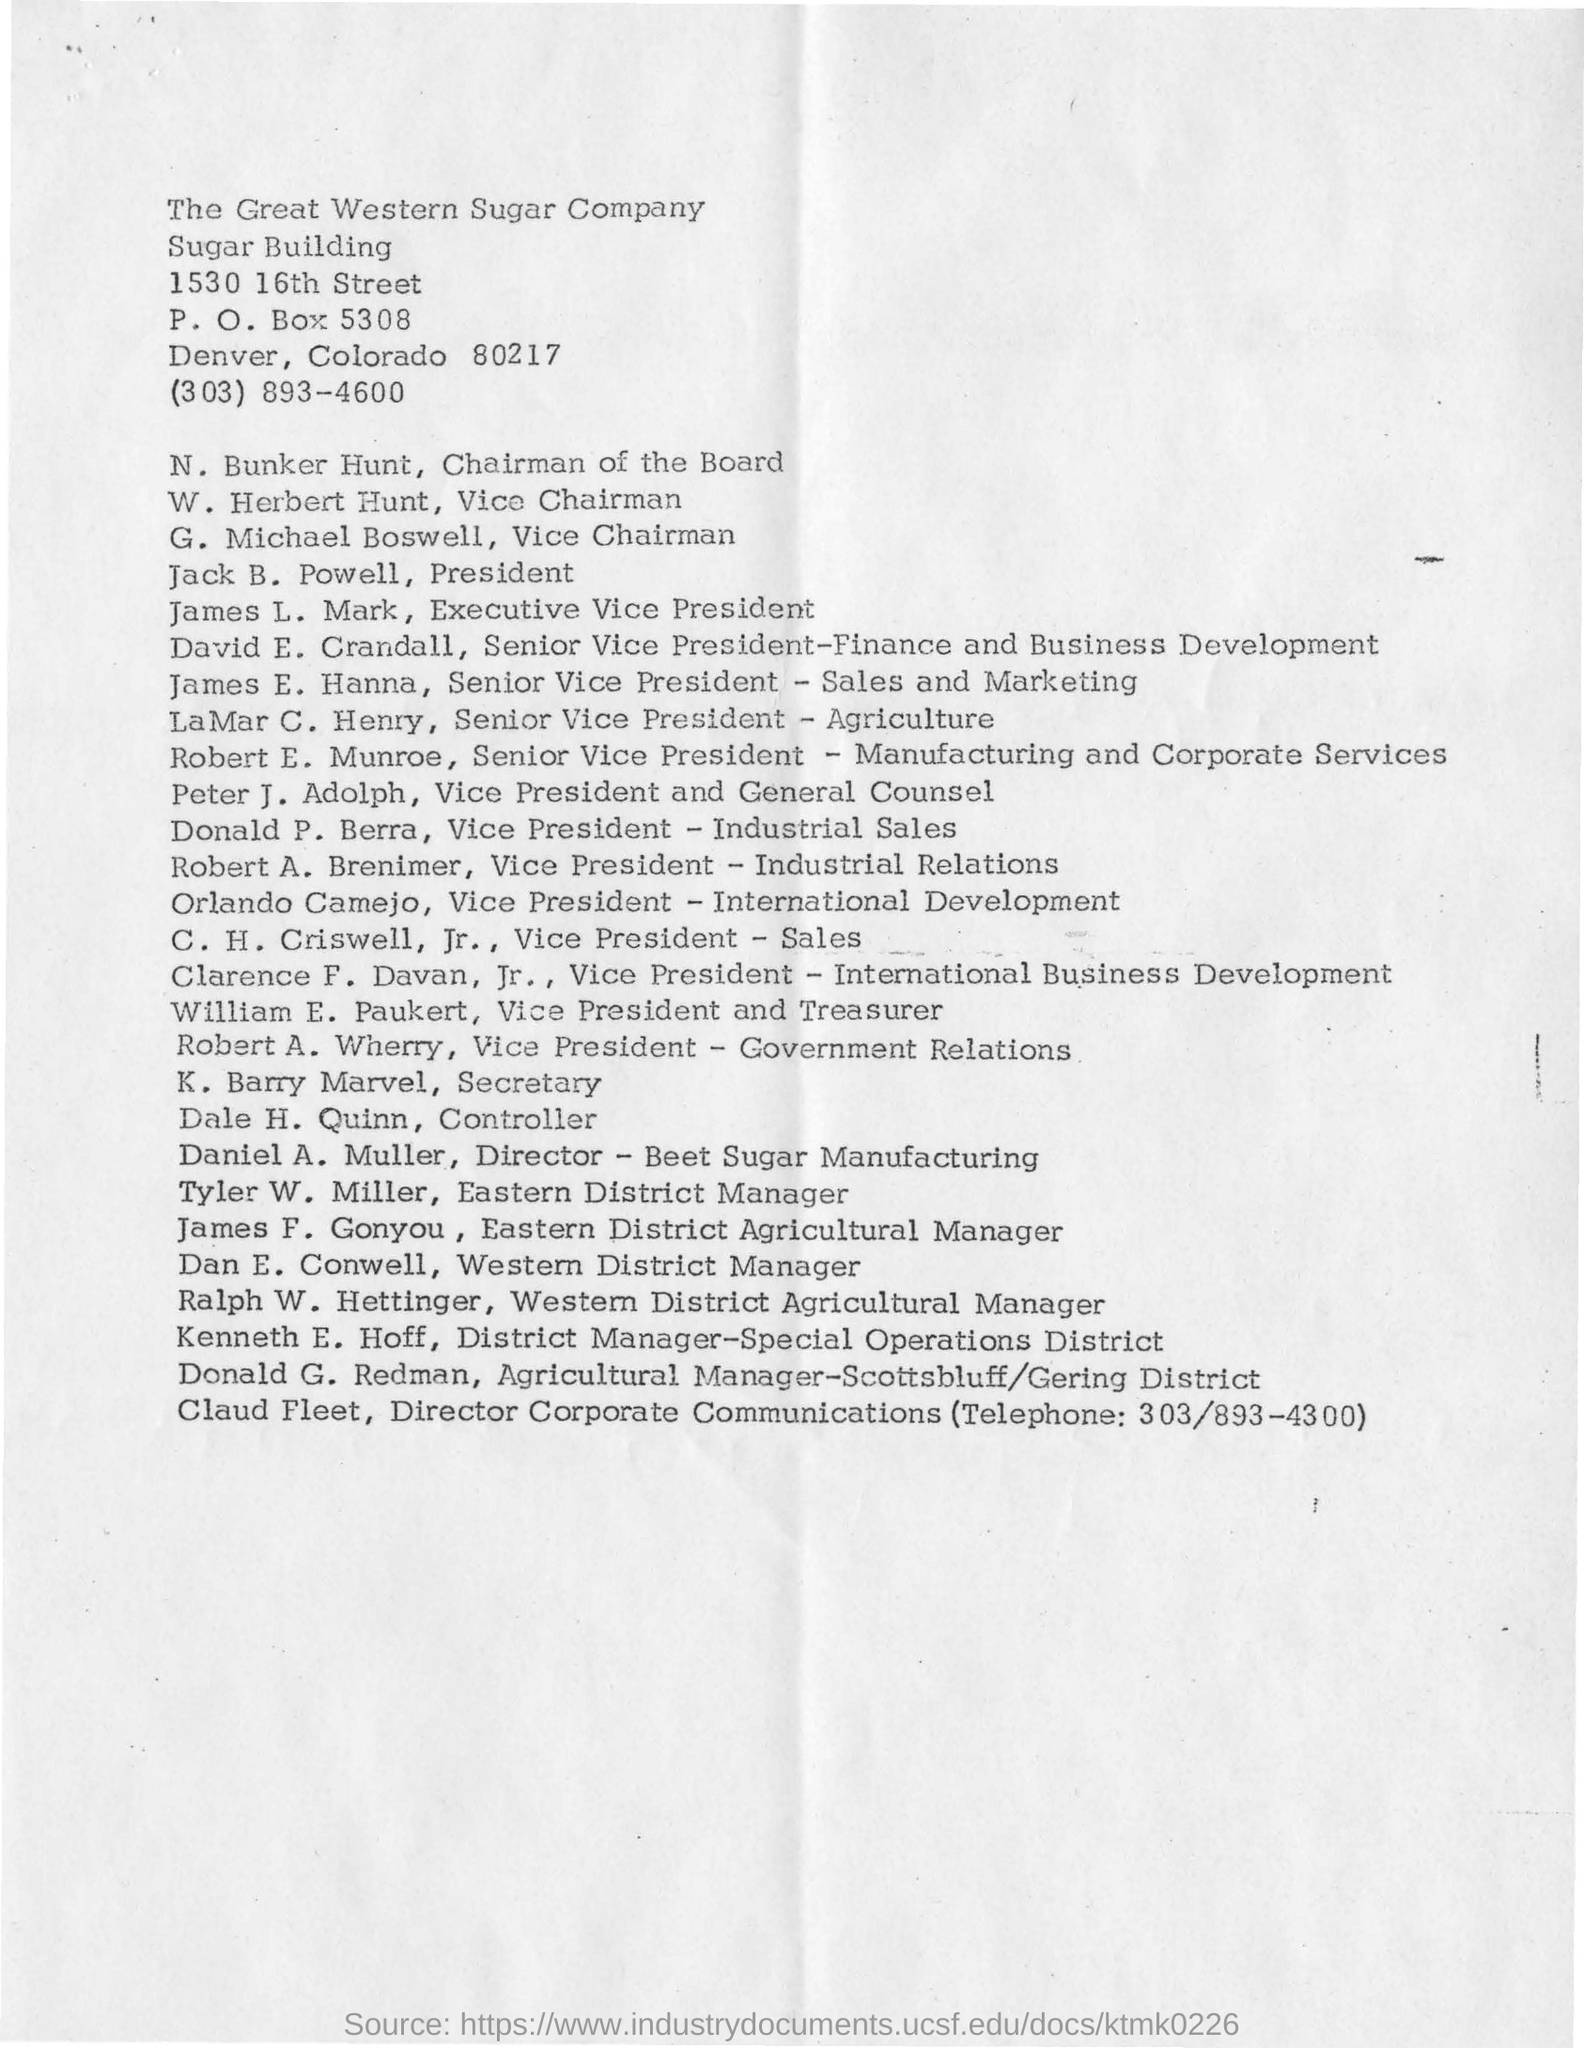Who is the Senior Vice President- Sales and Marketing?
Your response must be concise. James E. Hanna. What is the P.O.Box no given?
Provide a short and direct response. 5308. In which city, The Great Western Sugar Company is located?
Give a very brief answer. Denver. What is the designation of N. Bunker Hunt?
Ensure brevity in your answer.  Chairman of the Board. Who is the Director of Beet Sugar Manufacturing?
Provide a short and direct response. Daniel A. Muller. What is the telephone no of Director Corporate Communications?
Give a very brief answer. 303/893-4300. 